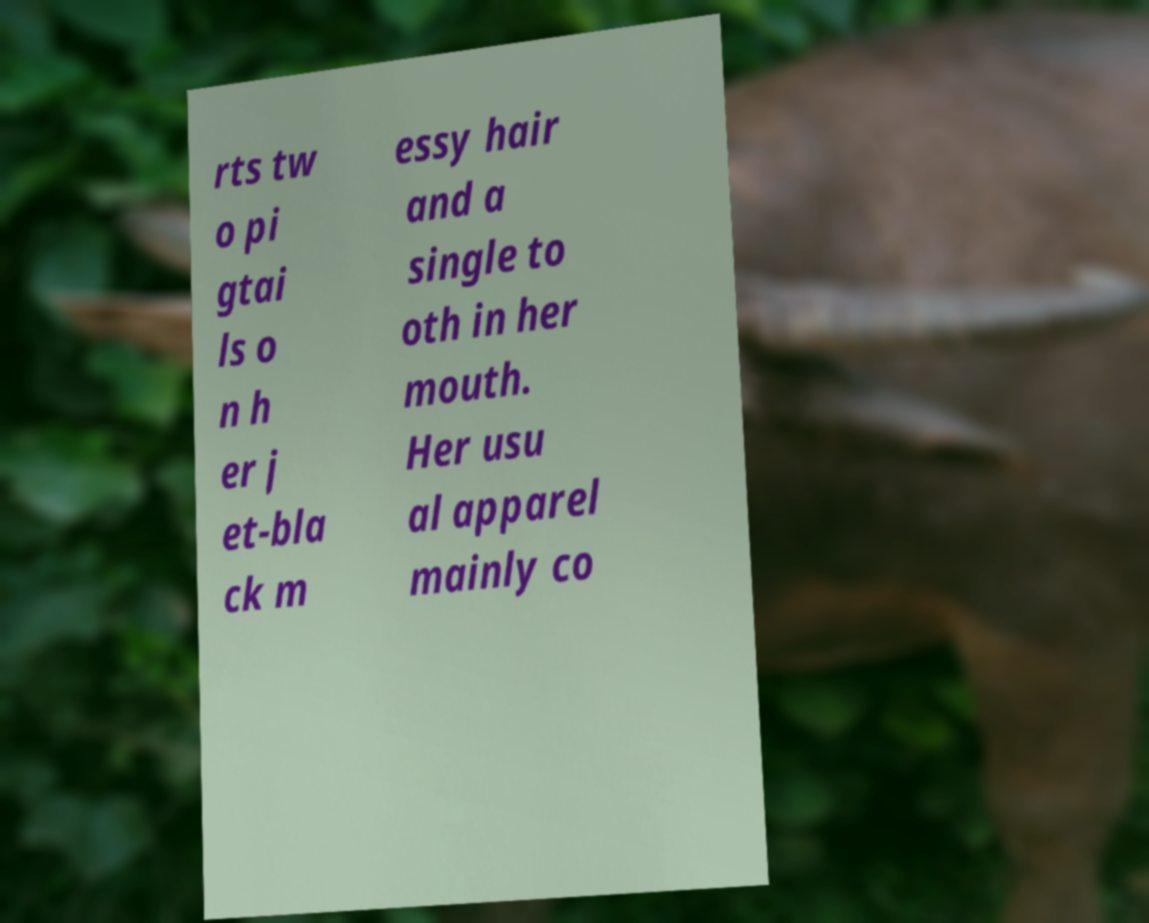There's text embedded in this image that I need extracted. Can you transcribe it verbatim? rts tw o pi gtai ls o n h er j et-bla ck m essy hair and a single to oth in her mouth. Her usu al apparel mainly co 